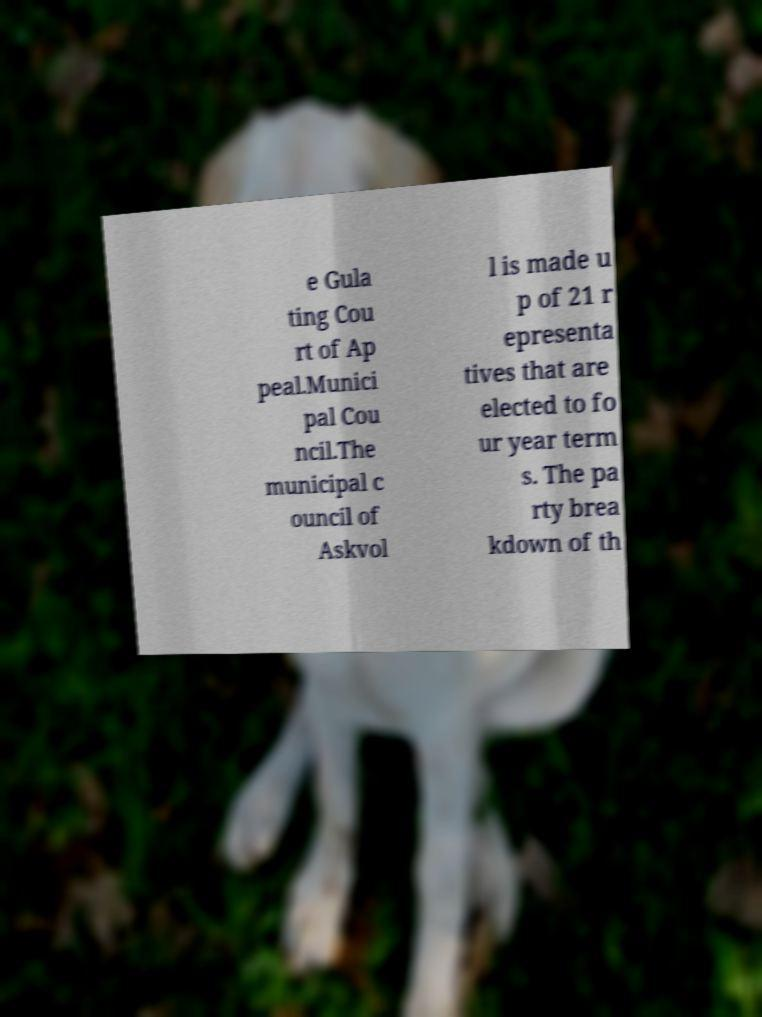Please read and relay the text visible in this image. What does it say? e Gula ting Cou rt of Ap peal.Munici pal Cou ncil.The municipal c ouncil of Askvol l is made u p of 21 r epresenta tives that are elected to fo ur year term s. The pa rty brea kdown of th 